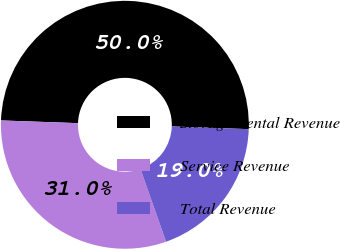<chart> <loc_0><loc_0><loc_500><loc_500><pie_chart><fcel>Storage Rental Revenue<fcel>Service Revenue<fcel>Total Revenue<nl><fcel>50.0%<fcel>30.95%<fcel>19.05%<nl></chart> 